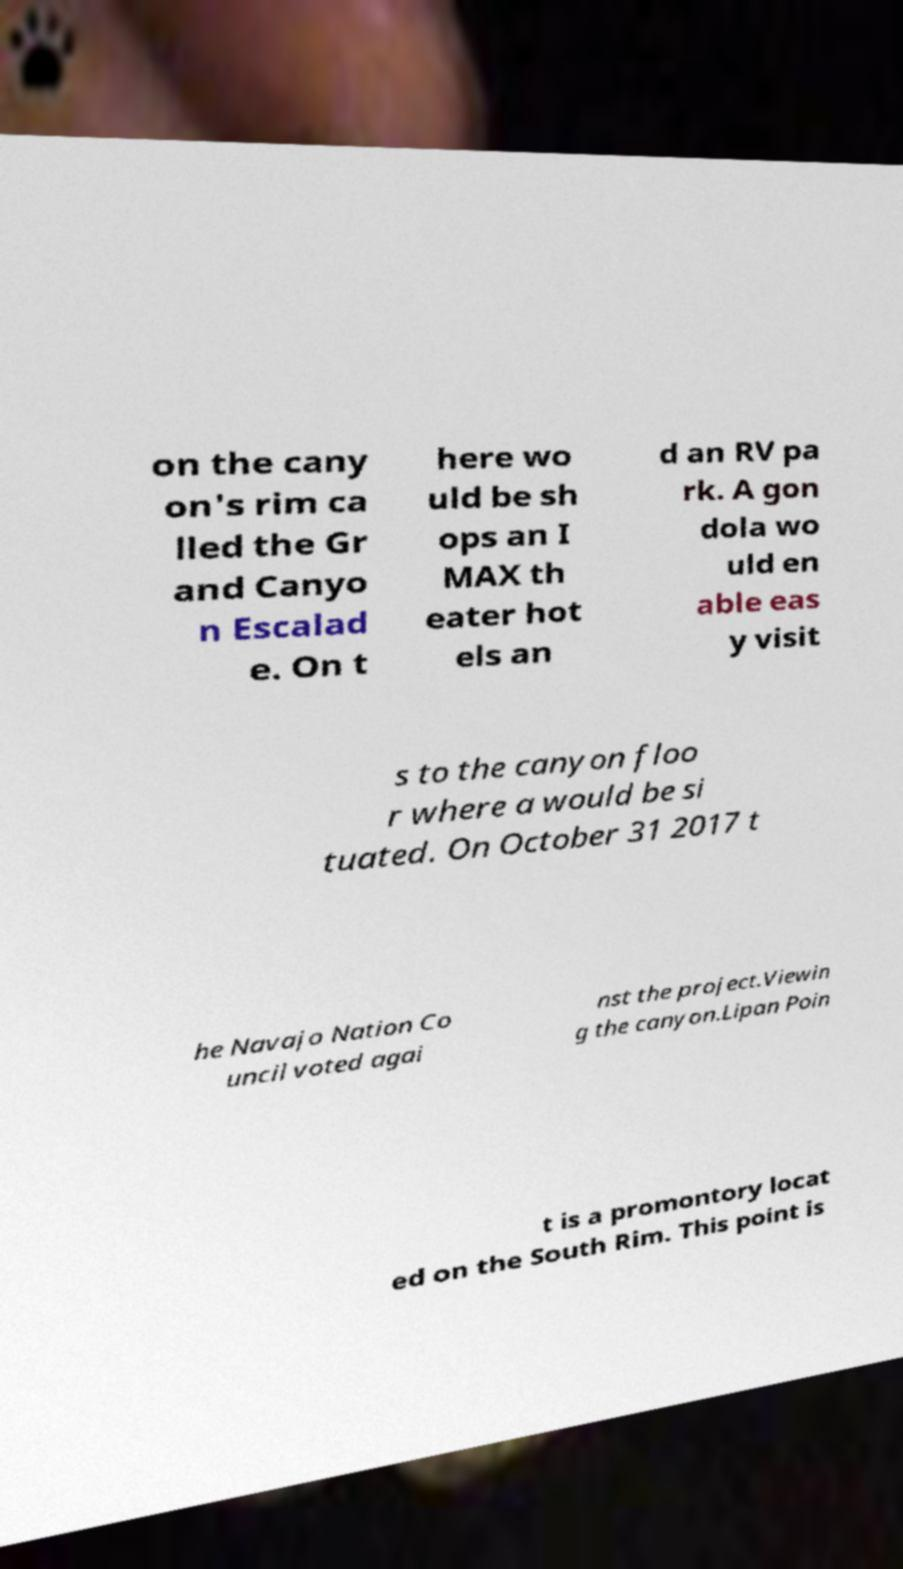Can you accurately transcribe the text from the provided image for me? on the cany on's rim ca lled the Gr and Canyo n Escalad e. On t here wo uld be sh ops an I MAX th eater hot els an d an RV pa rk. A gon dola wo uld en able eas y visit s to the canyon floo r where a would be si tuated. On October 31 2017 t he Navajo Nation Co uncil voted agai nst the project.Viewin g the canyon.Lipan Poin t is a promontory locat ed on the South Rim. This point is 